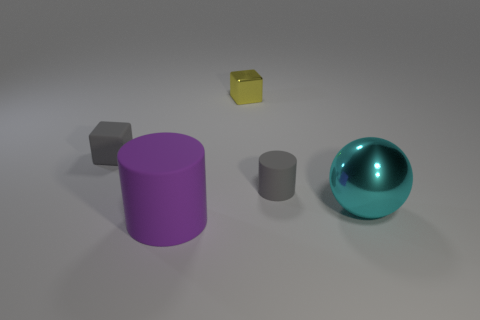Subtract all gray cubes. How many cubes are left? 1 Add 1 tiny gray cubes. How many objects exist? 6 Subtract 1 spheres. How many spheres are left? 0 Subtract all balls. How many objects are left? 4 Subtract all cyan cylinders. How many purple blocks are left? 0 Subtract all purple things. Subtract all gray rubber blocks. How many objects are left? 3 Add 5 cyan metallic spheres. How many cyan metallic spheres are left? 6 Add 2 big green cubes. How many big green cubes exist? 2 Subtract 0 purple cubes. How many objects are left? 5 Subtract all brown cylinders. Subtract all purple blocks. How many cylinders are left? 2 